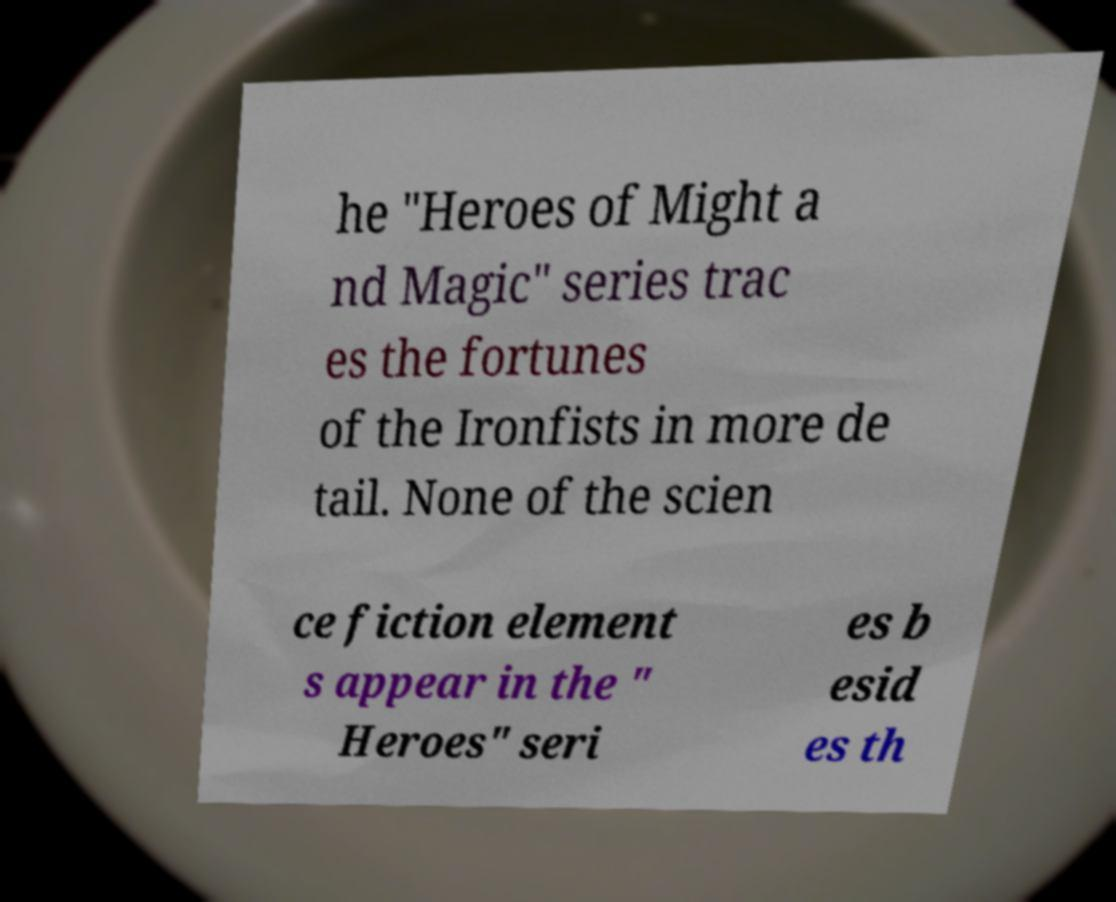For documentation purposes, I need the text within this image transcribed. Could you provide that? he "Heroes of Might a nd Magic" series trac es the fortunes of the Ironfists in more de tail. None of the scien ce fiction element s appear in the " Heroes" seri es b esid es th 